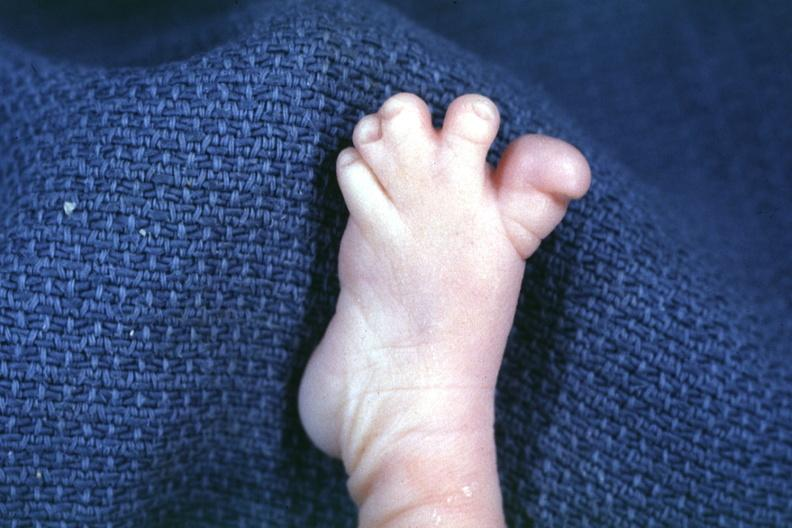s syndactyly present?
Answer the question using a single word or phrase. Yes 